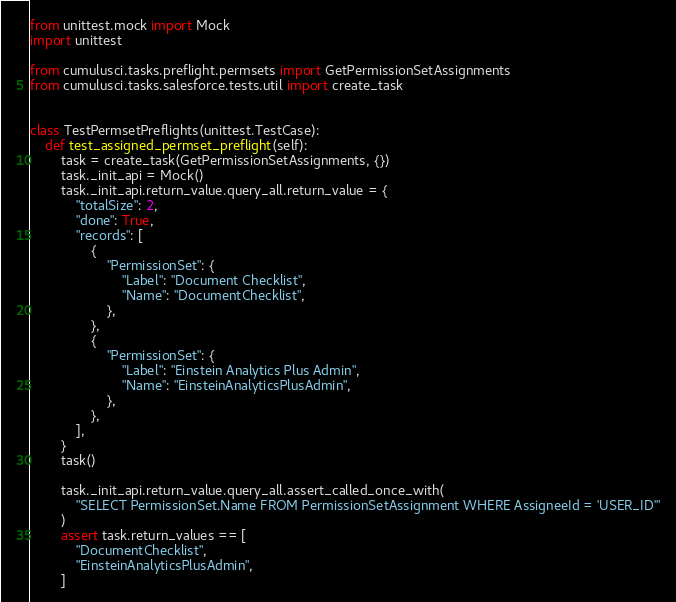Convert code to text. <code><loc_0><loc_0><loc_500><loc_500><_Python_>from unittest.mock import Mock
import unittest

from cumulusci.tasks.preflight.permsets import GetPermissionSetAssignments
from cumulusci.tasks.salesforce.tests.util import create_task


class TestPermsetPreflights(unittest.TestCase):
    def test_assigned_permset_preflight(self):
        task = create_task(GetPermissionSetAssignments, {})
        task._init_api = Mock()
        task._init_api.return_value.query_all.return_value = {
            "totalSize": 2,
            "done": True,
            "records": [
                {
                    "PermissionSet": {
                        "Label": "Document Checklist",
                        "Name": "DocumentChecklist",
                    },
                },
                {
                    "PermissionSet": {
                        "Label": "Einstein Analytics Plus Admin",
                        "Name": "EinsteinAnalyticsPlusAdmin",
                    },
                },
            ],
        }
        task()

        task._init_api.return_value.query_all.assert_called_once_with(
            "SELECT PermissionSet.Name FROM PermissionSetAssignment WHERE AssigneeId = 'USER_ID'"
        )
        assert task.return_values == [
            "DocumentChecklist",
            "EinsteinAnalyticsPlusAdmin",
        ]
</code> 